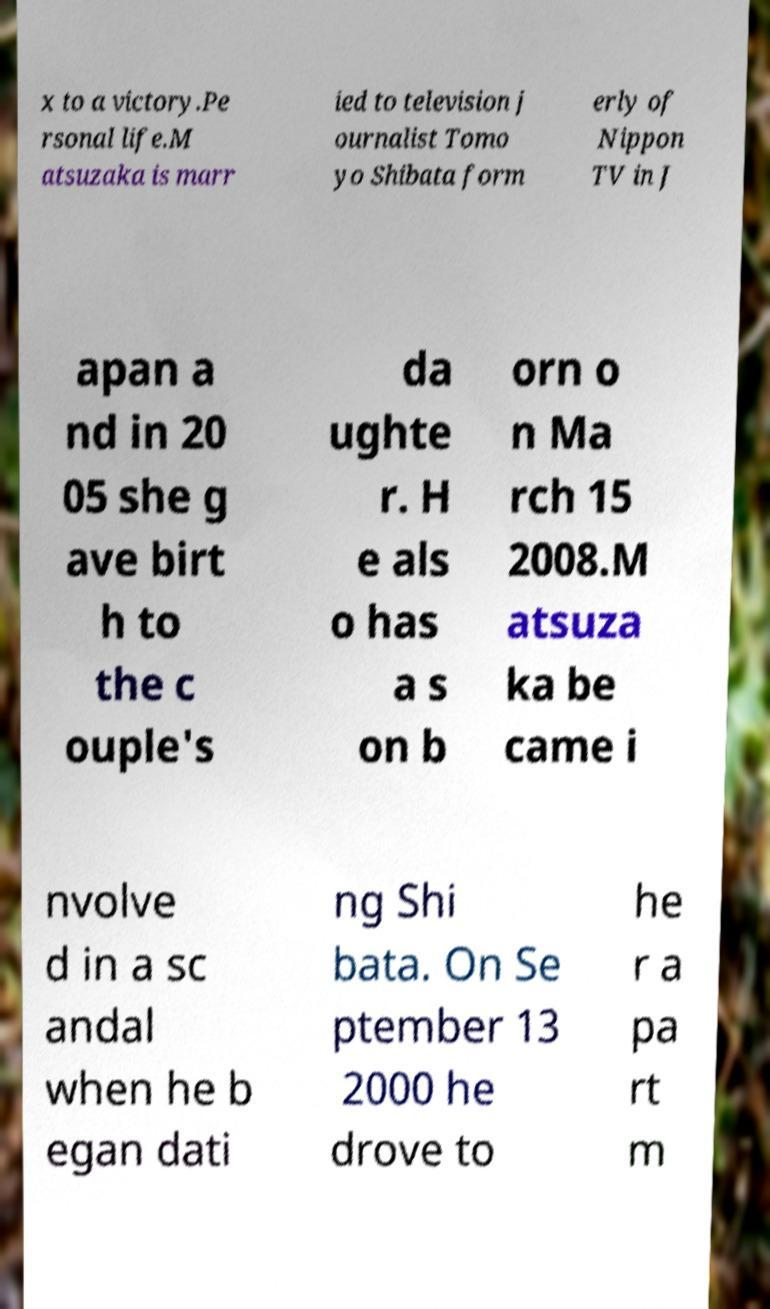Can you read and provide the text displayed in the image?This photo seems to have some interesting text. Can you extract and type it out for me? x to a victory.Pe rsonal life.M atsuzaka is marr ied to television j ournalist Tomo yo Shibata form erly of Nippon TV in J apan a nd in 20 05 she g ave birt h to the c ouple's da ughte r. H e als o has a s on b orn o n Ma rch 15 2008.M atsuza ka be came i nvolve d in a sc andal when he b egan dati ng Shi bata. On Se ptember 13 2000 he drove to he r a pa rt m 